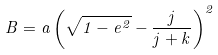Convert formula to latex. <formula><loc_0><loc_0><loc_500><loc_500>B = a \left ( \sqrt { 1 - e ^ { 2 } } - \frac { j } { j + k } \right ) ^ { 2 }</formula> 